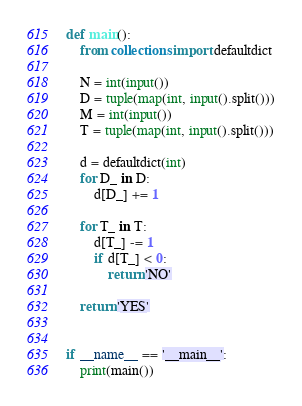Convert code to text. <code><loc_0><loc_0><loc_500><loc_500><_Python_>def main():
    from collections import defaultdict

    N = int(input())
    D = tuple(map(int, input().split()))
    M = int(input())
    T = tuple(map(int, input().split()))

    d = defaultdict(int)
    for D_ in D:
        d[D_] += 1

    for T_ in T:
        d[T_] -= 1
        if d[T_] < 0:
            return 'NO'

    return 'YES'


if __name__ == '__main__':
    print(main())
</code> 